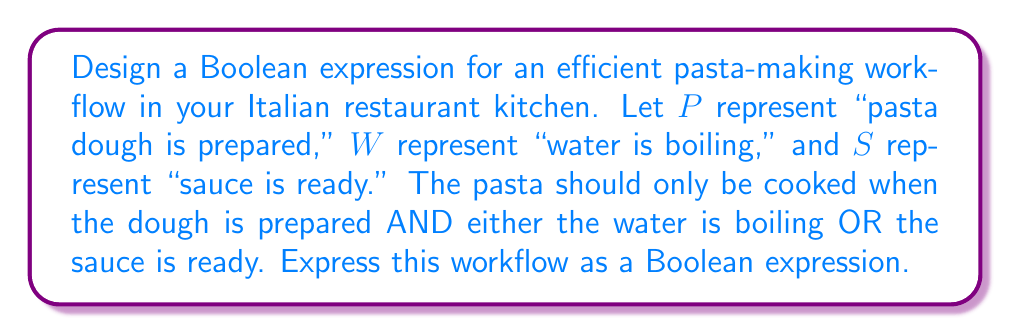Show me your answer to this math problem. Let's approach this step-by-step:

1) We need the pasta dough to be prepared in all cases, so $P$ must be true.

2) We also need either the water to be boiling OR the sauce to be ready. This can be expressed as $(W \lor S)$.

3) We need both conditions to be true simultaneously, so we use the AND operator $\land$ to combine them.

4) The resulting Boolean expression is:

   $$ P \land (W \lor S) $$

5) This expression reads as: "Pasta dough is prepared AND (water is boiling OR sauce is ready)"

6) In Boolean algebra, this is known as a conjunction of a single variable $(P)$ with a disjunction $(W \lor S)$.

7) This expression will only evaluate to true when $P$ is true AND either $W$ or $S$ (or both) are true, ensuring an efficient workflow in the pasta-making process.
Answer: $P \land (W \lor S)$ 